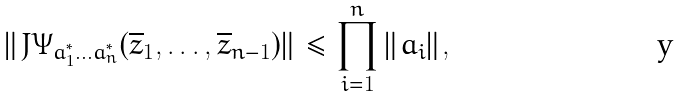<formula> <loc_0><loc_0><loc_500><loc_500>\| J \Psi _ { a _ { 1 } ^ { * } \dots a _ { n } ^ { * } } ( \overline { z } _ { 1 } , \dots , \overline { z } _ { n - 1 } ) \| \leq \prod _ { i = 1 } ^ { n } \| a _ { i } \| ,</formula> 